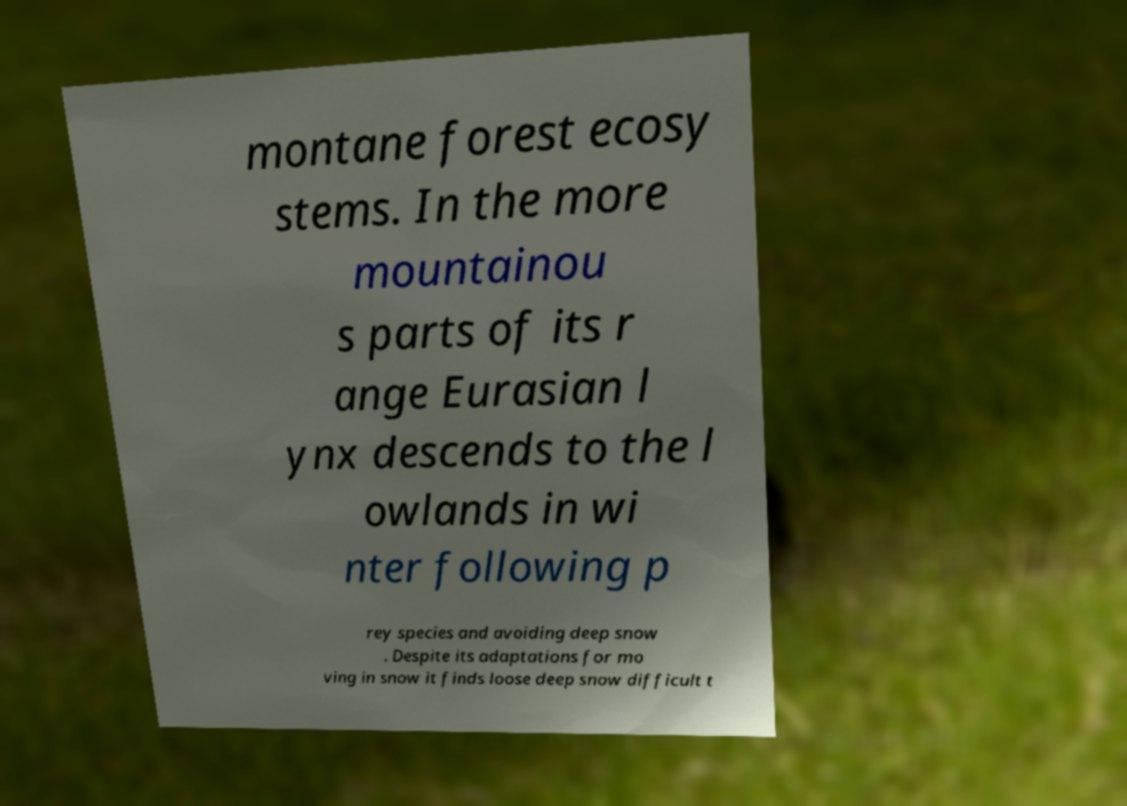There's text embedded in this image that I need extracted. Can you transcribe it verbatim? montane forest ecosy stems. In the more mountainou s parts of its r ange Eurasian l ynx descends to the l owlands in wi nter following p rey species and avoiding deep snow . Despite its adaptations for mo ving in snow it finds loose deep snow difficult t 